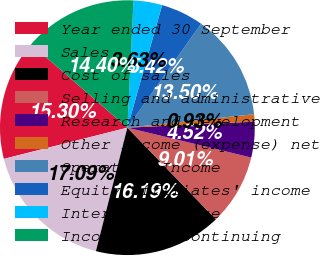Convert chart to OTSL. <chart><loc_0><loc_0><loc_500><loc_500><pie_chart><fcel>Year ended 30 September<fcel>Sales<fcel>Cost of sales<fcel>Selling and administrative<fcel>Research and development<fcel>Other income (expense) net<fcel>Operating Income<fcel>Equity affiliates' income<fcel>Interest expense<fcel>Income from Continuing<nl><fcel>15.3%<fcel>17.09%<fcel>16.19%<fcel>9.01%<fcel>4.52%<fcel>0.93%<fcel>13.5%<fcel>5.42%<fcel>3.63%<fcel>14.4%<nl></chart> 